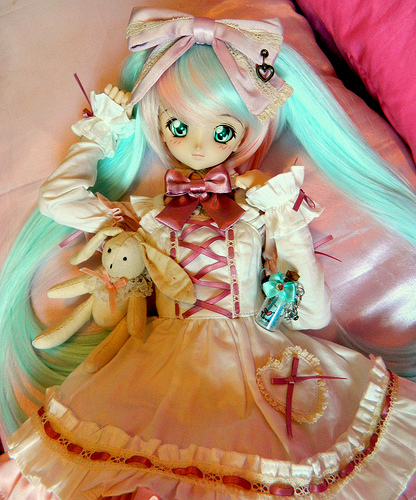<image>
Can you confirm if the rabbit is under the pillow? No. The rabbit is not positioned under the pillow. The vertical relationship between these objects is different. 